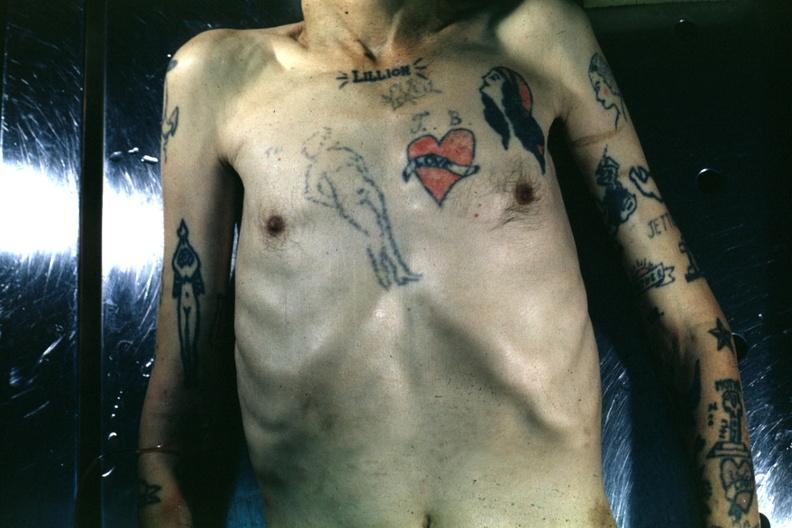does glomerulosa show upper portion of body with many tattoos?
Answer the question using a single word or phrase. No 